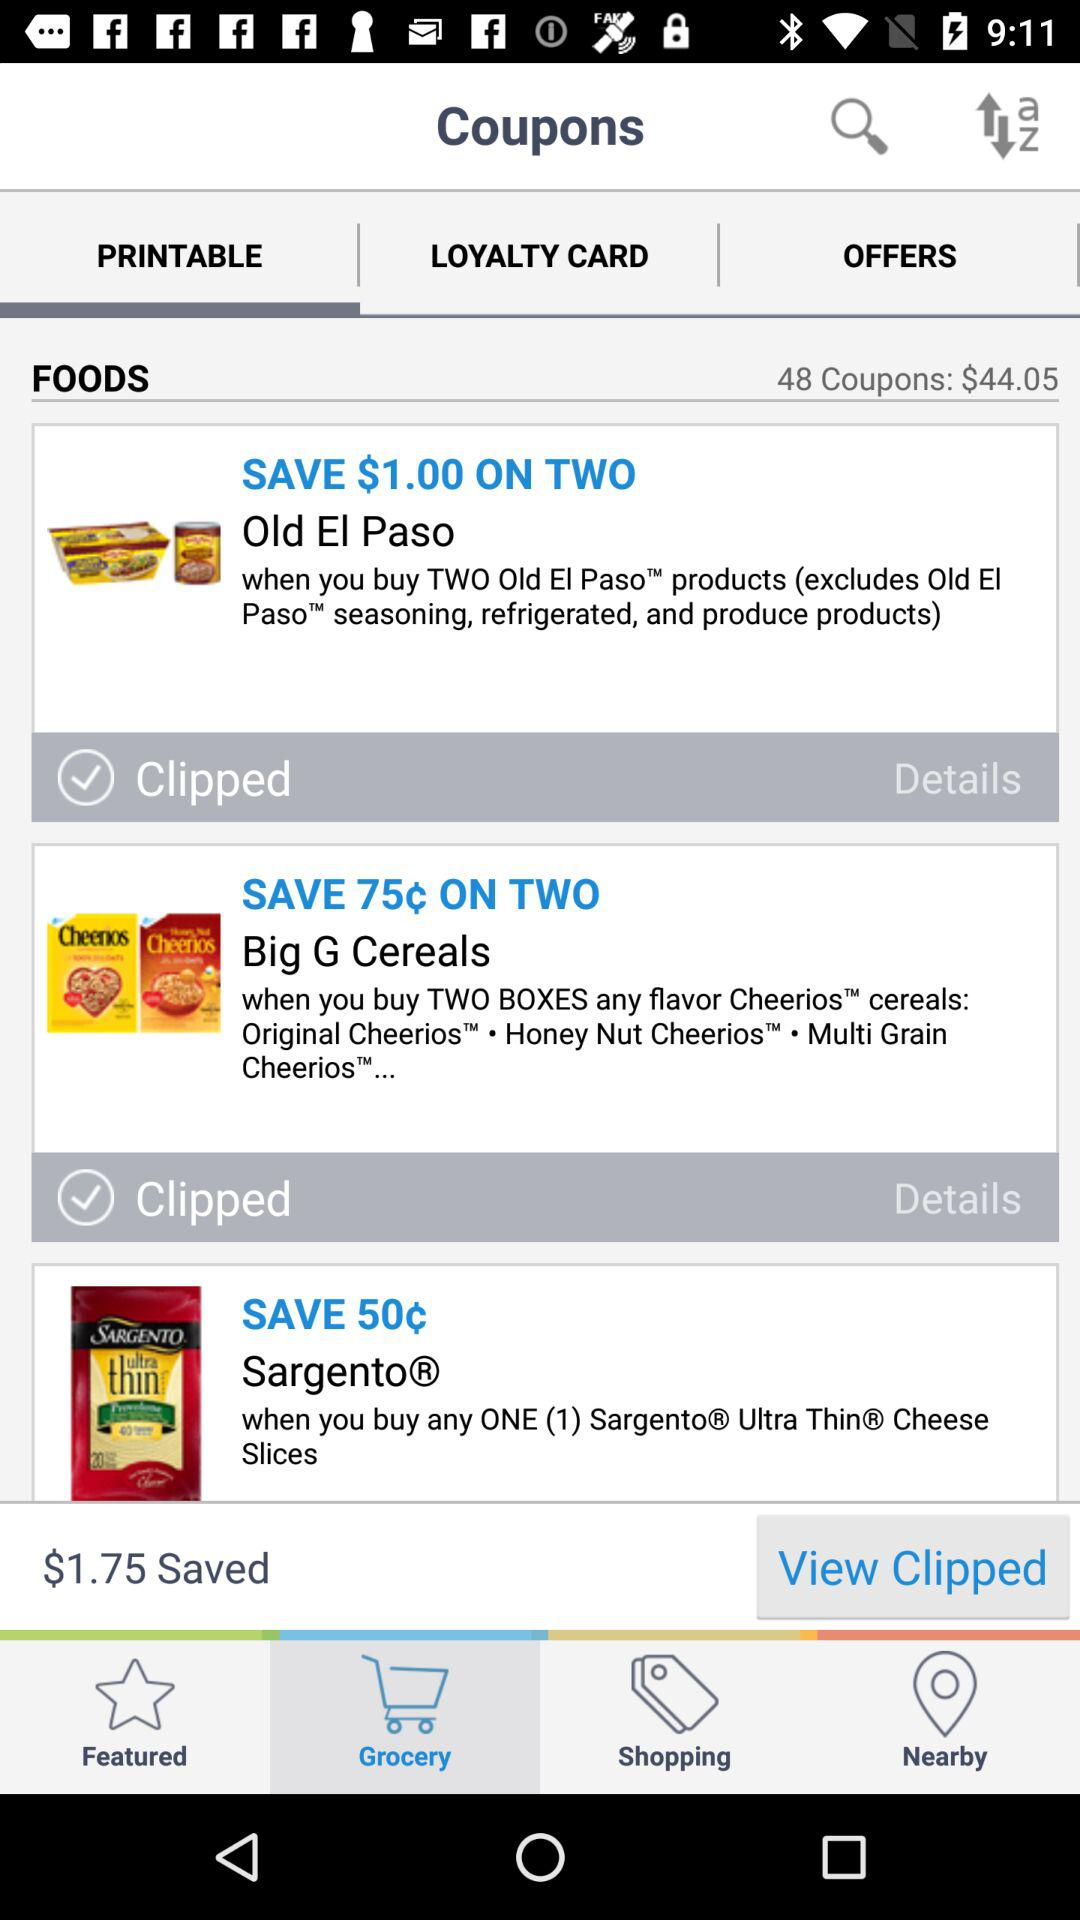How many cents can we save on the two packs of Big G cereals? On two packs of Big G cereal, you can save 75¢. 